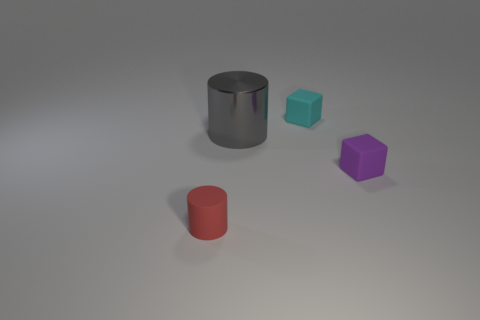Are there any other things that have the same material as the large cylinder?
Provide a short and direct response. No. Are there any other things that have the same size as the metallic thing?
Offer a very short reply. No. What number of things are objects right of the rubber cylinder or purple things?
Keep it short and to the point. 3. The cylinder that is the same material as the small purple cube is what color?
Offer a very short reply. Red. Are there any green rubber blocks of the same size as the shiny thing?
Give a very brief answer. No. What number of objects are things on the right side of the tiny red rubber cylinder or rubber blocks in front of the shiny cylinder?
Offer a terse response. 3. There is a red thing that is the same size as the cyan thing; what shape is it?
Provide a short and direct response. Cylinder. Is there a small purple matte object that has the same shape as the big gray thing?
Your answer should be very brief. No. Is the number of objects less than the number of tiny cubes?
Your answer should be compact. No. There is a gray metal cylinder behind the small purple thing; is its size the same as the cylinder that is in front of the big gray thing?
Provide a succinct answer. No. 